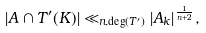<formula> <loc_0><loc_0><loc_500><loc_500>| A \cap T ^ { \prime } ( K ) | \ll _ { n , \deg ( T ^ { \prime } ) } | A _ { k } | ^ { \frac { 1 } { n + 2 } } ,</formula> 